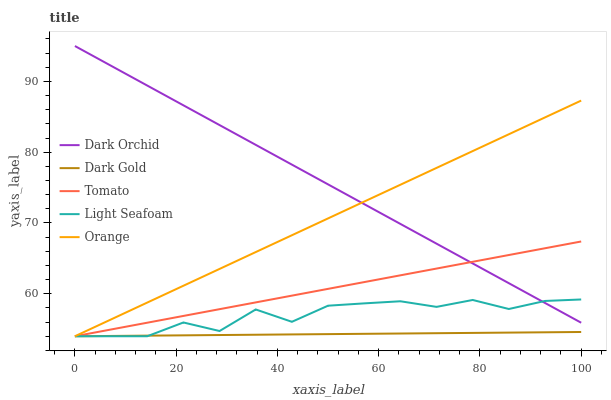Does Dark Gold have the minimum area under the curve?
Answer yes or no. Yes. Does Dark Orchid have the maximum area under the curve?
Answer yes or no. Yes. Does Orange have the minimum area under the curve?
Answer yes or no. No. Does Orange have the maximum area under the curve?
Answer yes or no. No. Is Dark Gold the smoothest?
Answer yes or no. Yes. Is Light Seafoam the roughest?
Answer yes or no. Yes. Is Orange the smoothest?
Answer yes or no. No. Is Orange the roughest?
Answer yes or no. No. Does Tomato have the lowest value?
Answer yes or no. Yes. Does Dark Orchid have the lowest value?
Answer yes or no. No. Does Dark Orchid have the highest value?
Answer yes or no. Yes. Does Orange have the highest value?
Answer yes or no. No. Is Dark Gold less than Dark Orchid?
Answer yes or no. Yes. Is Dark Orchid greater than Dark Gold?
Answer yes or no. Yes. Does Orange intersect Tomato?
Answer yes or no. Yes. Is Orange less than Tomato?
Answer yes or no. No. Is Orange greater than Tomato?
Answer yes or no. No. Does Dark Gold intersect Dark Orchid?
Answer yes or no. No. 